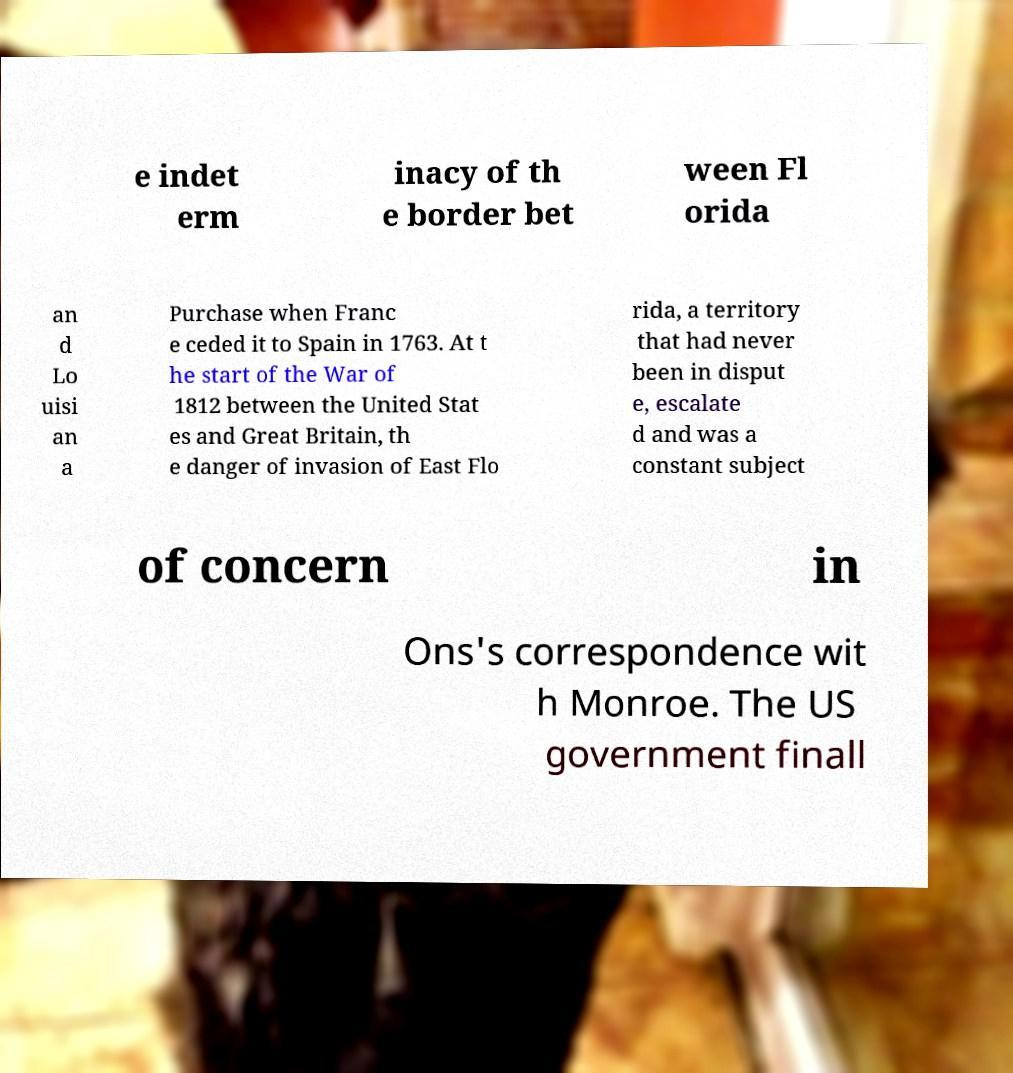Please read and relay the text visible in this image. What does it say? e indet erm inacy of th e border bet ween Fl orida an d Lo uisi an a Purchase when Franc e ceded it to Spain in 1763. At t he start of the War of 1812 between the United Stat es and Great Britain, th e danger of invasion of East Flo rida, a territory that had never been in disput e, escalate d and was a constant subject of concern in Ons's correspondence wit h Monroe. The US government finall 